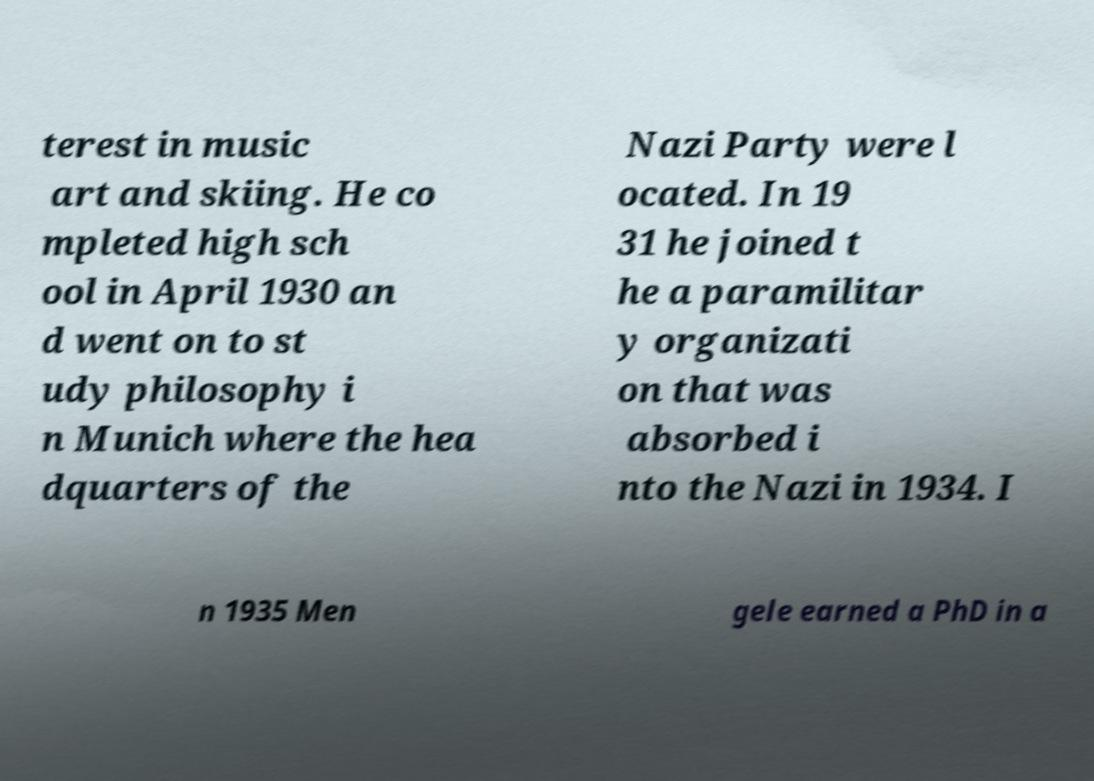Please read and relay the text visible in this image. What does it say? terest in music art and skiing. He co mpleted high sch ool in April 1930 an d went on to st udy philosophy i n Munich where the hea dquarters of the Nazi Party were l ocated. In 19 31 he joined t he a paramilitar y organizati on that was absorbed i nto the Nazi in 1934. I n 1935 Men gele earned a PhD in a 